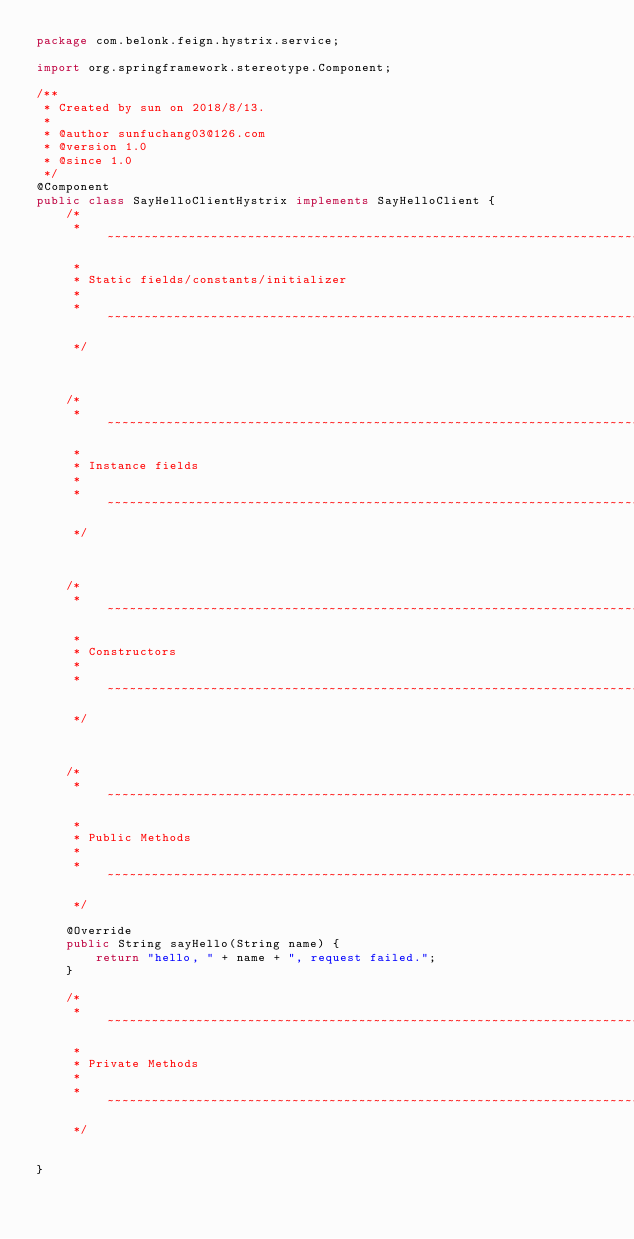Convert code to text. <code><loc_0><loc_0><loc_500><loc_500><_Java_>package com.belonk.feign.hystrix.service;

import org.springframework.stereotype.Component;

/**
 * Created by sun on 2018/8/13.
 *
 * @author sunfuchang03@126.com
 * @version 1.0
 * @since 1.0
 */
@Component
public class SayHelloClientHystrix implements SayHelloClient {
    /*
     * ~~~~~~~~~~~~~~~~~~~~~~~~~~~~~~~~~~~~~~~~~~~~~~~~~~~~~~~~~~~~~~~~~~~~~~~~~~~~~~~~~~~~~~~~~~~~~~~~~~~~~~~~~~~~~~~~~
     *
     * Static fields/constants/initializer
     *
     * ~~~~~~~~~~~~~~~~~~~~~~~~~~~~~~~~~~~~~~~~~~~~~~~~~~~~~~~~~~~~~~~~~~~~~~~~~~~~~~~~~~~~~~~~~~~~~~~~~~~~~~~~~~~~~~~~~
     */



    /*
     * ~~~~~~~~~~~~~~~~~~~~~~~~~~~~~~~~~~~~~~~~~~~~~~~~~~~~~~~~~~~~~~~~~~~~~~~~~~~~~~~~~~~~~~~~~~~~~~~~~~~~~~~~~~~~~~~~~
     *
     * Instance fields
     *
     * ~~~~~~~~~~~~~~~~~~~~~~~~~~~~~~~~~~~~~~~~~~~~~~~~~~~~~~~~~~~~~~~~~~~~~~~~~~~~~~~~~~~~~~~~~~~~~~~~~~~~~~~~~~~~~~~~~
     */



    /*
     * ~~~~~~~~~~~~~~~~~~~~~~~~~~~~~~~~~~~~~~~~~~~~~~~~~~~~~~~~~~~~~~~~~~~~~~~~~~~~~~~~~~~~~~~~~~~~~~~~~~~~~~~~~~~~~~~~~
     *
     * Constructors
     *
     * ~~~~~~~~~~~~~~~~~~~~~~~~~~~~~~~~~~~~~~~~~~~~~~~~~~~~~~~~~~~~~~~~~~~~~~~~~~~~~~~~~~~~~~~~~~~~~~~~~~~~~~~~~~~~~~~~~
     */



    /*
     * ~~~~~~~~~~~~~~~~~~~~~~~~~~~~~~~~~~~~~~~~~~~~~~~~~~~~~~~~~~~~~~~~~~~~~~~~~~~~~~~~~~~~~~~~~~~~~~~~~~~~~~~~~~~~~~~~~
     *
     * Public Methods
     *
     * ~~~~~~~~~~~~~~~~~~~~~~~~~~~~~~~~~~~~~~~~~~~~~~~~~~~~~~~~~~~~~~~~~~~~~~~~~~~~~~~~~~~~~~~~~~~~~~~~~~~~~~~~~~~~~~~~~
     */

    @Override
    public String sayHello(String name) {
        return "hello, " + name + ", request failed.";
    }

    /*
     * ~~~~~~~~~~~~~~~~~~~~~~~~~~~~~~~~~~~~~~~~~~~~~~~~~~~~~~~~~~~~~~~~~~~~~~~~~~~~~~~~~~~~~~~~~~~~~~~~~~~~~~~~~~~~~~~~~
     *
     * Private Methods
     *
     * ~~~~~~~~~~~~~~~~~~~~~~~~~~~~~~~~~~~~~~~~~~~~~~~~~~~~~~~~~~~~~~~~~~~~~~~~~~~~~~~~~~~~~~~~~~~~~~~~~~~~~~~~~~~~~~~~~
     */


}</code> 